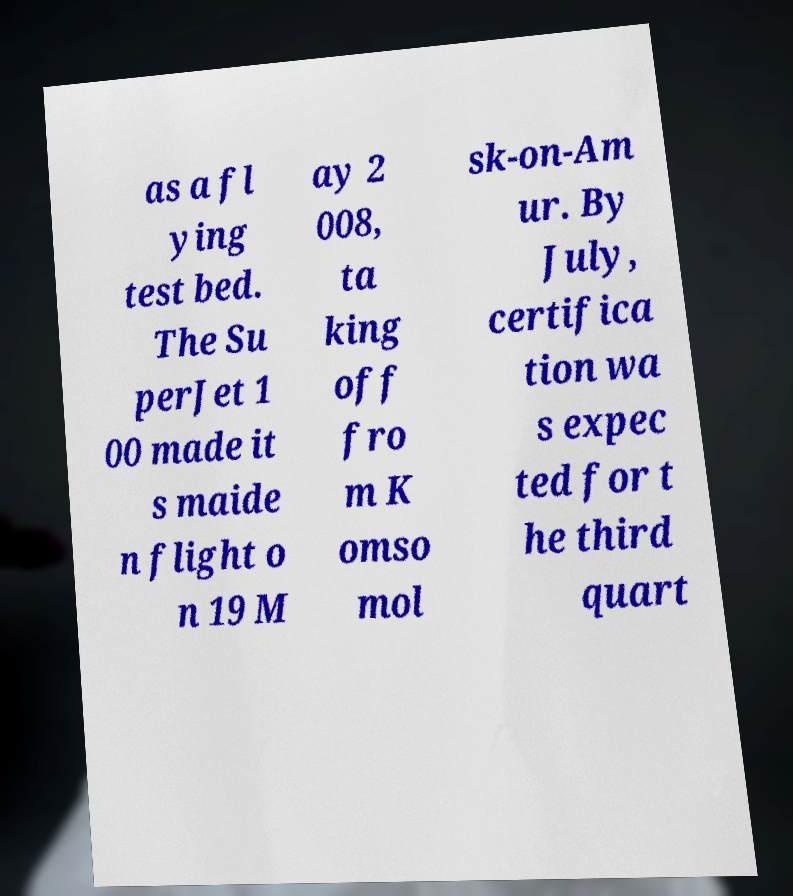There's text embedded in this image that I need extracted. Can you transcribe it verbatim? as a fl ying test bed. The Su perJet 1 00 made it s maide n flight o n 19 M ay 2 008, ta king off fro m K omso mol sk-on-Am ur. By July, certifica tion wa s expec ted for t he third quart 